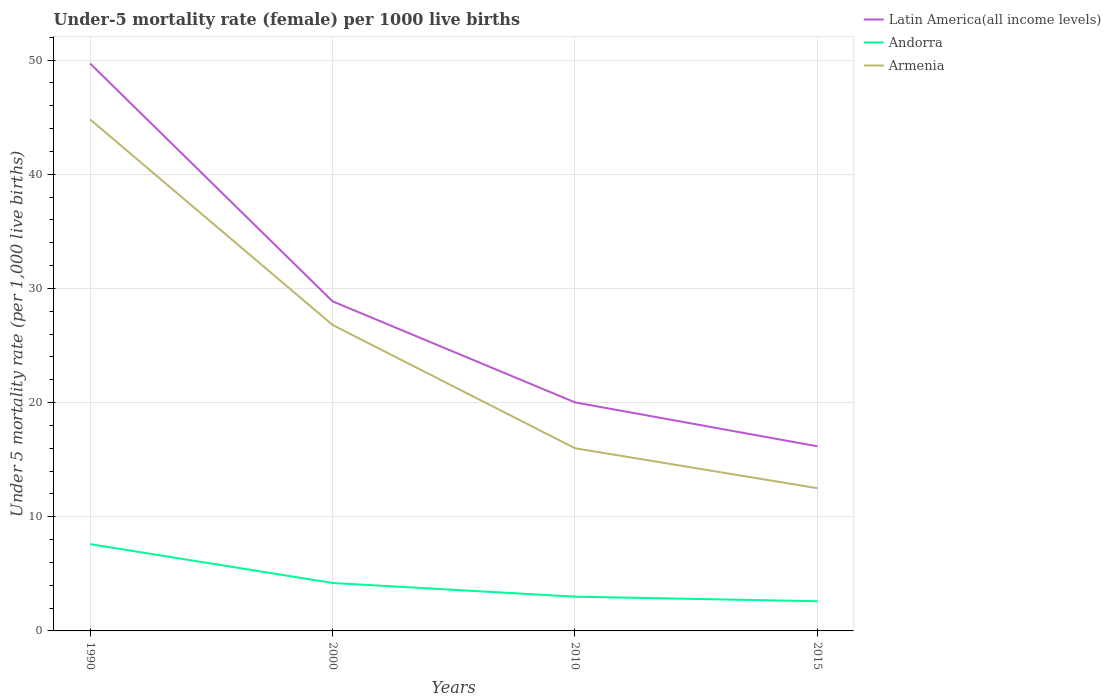Does the line corresponding to Latin America(all income levels) intersect with the line corresponding to Armenia?
Keep it short and to the point. No. Across all years, what is the maximum under-five mortality rate in Armenia?
Your answer should be very brief. 12.5. In which year was the under-five mortality rate in Latin America(all income levels) maximum?
Make the answer very short. 2015. What is the total under-five mortality rate in Armenia in the graph?
Provide a succinct answer. 28.8. What is the difference between the highest and the lowest under-five mortality rate in Andorra?
Provide a succinct answer. 1. How many lines are there?
Keep it short and to the point. 3. Does the graph contain grids?
Offer a terse response. Yes. Where does the legend appear in the graph?
Your response must be concise. Top right. What is the title of the graph?
Keep it short and to the point. Under-5 mortality rate (female) per 1000 live births. What is the label or title of the Y-axis?
Provide a short and direct response. Under 5 mortality rate (per 1,0 live births). What is the Under 5 mortality rate (per 1,000 live births) in Latin America(all income levels) in 1990?
Your answer should be very brief. 49.7. What is the Under 5 mortality rate (per 1,000 live births) of Andorra in 1990?
Give a very brief answer. 7.6. What is the Under 5 mortality rate (per 1,000 live births) of Armenia in 1990?
Keep it short and to the point. 44.8. What is the Under 5 mortality rate (per 1,000 live births) of Latin America(all income levels) in 2000?
Your answer should be very brief. 28.87. What is the Under 5 mortality rate (per 1,000 live births) of Andorra in 2000?
Provide a short and direct response. 4.2. What is the Under 5 mortality rate (per 1,000 live births) of Armenia in 2000?
Your answer should be compact. 26.8. What is the Under 5 mortality rate (per 1,000 live births) in Latin America(all income levels) in 2010?
Give a very brief answer. 20.02. What is the Under 5 mortality rate (per 1,000 live births) of Armenia in 2010?
Keep it short and to the point. 16. What is the Under 5 mortality rate (per 1,000 live births) of Latin America(all income levels) in 2015?
Provide a short and direct response. 16.17. What is the Under 5 mortality rate (per 1,000 live births) of Andorra in 2015?
Keep it short and to the point. 2.6. Across all years, what is the maximum Under 5 mortality rate (per 1,000 live births) of Latin America(all income levels)?
Give a very brief answer. 49.7. Across all years, what is the maximum Under 5 mortality rate (per 1,000 live births) of Andorra?
Ensure brevity in your answer.  7.6. Across all years, what is the maximum Under 5 mortality rate (per 1,000 live births) in Armenia?
Your response must be concise. 44.8. Across all years, what is the minimum Under 5 mortality rate (per 1,000 live births) in Latin America(all income levels)?
Ensure brevity in your answer.  16.17. Across all years, what is the minimum Under 5 mortality rate (per 1,000 live births) of Andorra?
Ensure brevity in your answer.  2.6. What is the total Under 5 mortality rate (per 1,000 live births) of Latin America(all income levels) in the graph?
Offer a terse response. 114.75. What is the total Under 5 mortality rate (per 1,000 live births) of Armenia in the graph?
Provide a short and direct response. 100.1. What is the difference between the Under 5 mortality rate (per 1,000 live births) of Latin America(all income levels) in 1990 and that in 2000?
Ensure brevity in your answer.  20.83. What is the difference between the Under 5 mortality rate (per 1,000 live births) in Andorra in 1990 and that in 2000?
Give a very brief answer. 3.4. What is the difference between the Under 5 mortality rate (per 1,000 live births) of Latin America(all income levels) in 1990 and that in 2010?
Keep it short and to the point. 29.68. What is the difference between the Under 5 mortality rate (per 1,000 live births) in Armenia in 1990 and that in 2010?
Offer a terse response. 28.8. What is the difference between the Under 5 mortality rate (per 1,000 live births) of Latin America(all income levels) in 1990 and that in 2015?
Offer a terse response. 33.53. What is the difference between the Under 5 mortality rate (per 1,000 live births) in Armenia in 1990 and that in 2015?
Your response must be concise. 32.3. What is the difference between the Under 5 mortality rate (per 1,000 live births) of Latin America(all income levels) in 2000 and that in 2010?
Offer a terse response. 8.85. What is the difference between the Under 5 mortality rate (per 1,000 live births) in Andorra in 2000 and that in 2010?
Make the answer very short. 1.2. What is the difference between the Under 5 mortality rate (per 1,000 live births) in Armenia in 2000 and that in 2010?
Ensure brevity in your answer.  10.8. What is the difference between the Under 5 mortality rate (per 1,000 live births) in Latin America(all income levels) in 2000 and that in 2015?
Your answer should be very brief. 12.7. What is the difference between the Under 5 mortality rate (per 1,000 live births) in Andorra in 2000 and that in 2015?
Offer a terse response. 1.6. What is the difference between the Under 5 mortality rate (per 1,000 live births) in Armenia in 2000 and that in 2015?
Your answer should be compact. 14.3. What is the difference between the Under 5 mortality rate (per 1,000 live births) in Latin America(all income levels) in 2010 and that in 2015?
Ensure brevity in your answer.  3.85. What is the difference between the Under 5 mortality rate (per 1,000 live births) of Latin America(all income levels) in 1990 and the Under 5 mortality rate (per 1,000 live births) of Andorra in 2000?
Make the answer very short. 45.5. What is the difference between the Under 5 mortality rate (per 1,000 live births) of Latin America(all income levels) in 1990 and the Under 5 mortality rate (per 1,000 live births) of Armenia in 2000?
Keep it short and to the point. 22.9. What is the difference between the Under 5 mortality rate (per 1,000 live births) in Andorra in 1990 and the Under 5 mortality rate (per 1,000 live births) in Armenia in 2000?
Make the answer very short. -19.2. What is the difference between the Under 5 mortality rate (per 1,000 live births) of Latin America(all income levels) in 1990 and the Under 5 mortality rate (per 1,000 live births) of Andorra in 2010?
Offer a terse response. 46.7. What is the difference between the Under 5 mortality rate (per 1,000 live births) of Latin America(all income levels) in 1990 and the Under 5 mortality rate (per 1,000 live births) of Armenia in 2010?
Your response must be concise. 33.7. What is the difference between the Under 5 mortality rate (per 1,000 live births) in Andorra in 1990 and the Under 5 mortality rate (per 1,000 live births) in Armenia in 2010?
Provide a short and direct response. -8.4. What is the difference between the Under 5 mortality rate (per 1,000 live births) of Latin America(all income levels) in 1990 and the Under 5 mortality rate (per 1,000 live births) of Andorra in 2015?
Offer a terse response. 47.1. What is the difference between the Under 5 mortality rate (per 1,000 live births) of Latin America(all income levels) in 1990 and the Under 5 mortality rate (per 1,000 live births) of Armenia in 2015?
Your answer should be compact. 37.2. What is the difference between the Under 5 mortality rate (per 1,000 live births) in Latin America(all income levels) in 2000 and the Under 5 mortality rate (per 1,000 live births) in Andorra in 2010?
Offer a very short reply. 25.87. What is the difference between the Under 5 mortality rate (per 1,000 live births) of Latin America(all income levels) in 2000 and the Under 5 mortality rate (per 1,000 live births) of Armenia in 2010?
Give a very brief answer. 12.87. What is the difference between the Under 5 mortality rate (per 1,000 live births) of Latin America(all income levels) in 2000 and the Under 5 mortality rate (per 1,000 live births) of Andorra in 2015?
Offer a very short reply. 26.27. What is the difference between the Under 5 mortality rate (per 1,000 live births) in Latin America(all income levels) in 2000 and the Under 5 mortality rate (per 1,000 live births) in Armenia in 2015?
Offer a very short reply. 16.37. What is the difference between the Under 5 mortality rate (per 1,000 live births) in Latin America(all income levels) in 2010 and the Under 5 mortality rate (per 1,000 live births) in Andorra in 2015?
Offer a very short reply. 17.42. What is the difference between the Under 5 mortality rate (per 1,000 live births) of Latin America(all income levels) in 2010 and the Under 5 mortality rate (per 1,000 live births) of Armenia in 2015?
Keep it short and to the point. 7.52. What is the difference between the Under 5 mortality rate (per 1,000 live births) in Andorra in 2010 and the Under 5 mortality rate (per 1,000 live births) in Armenia in 2015?
Provide a short and direct response. -9.5. What is the average Under 5 mortality rate (per 1,000 live births) of Latin America(all income levels) per year?
Ensure brevity in your answer.  28.69. What is the average Under 5 mortality rate (per 1,000 live births) of Andorra per year?
Offer a terse response. 4.35. What is the average Under 5 mortality rate (per 1,000 live births) of Armenia per year?
Make the answer very short. 25.02. In the year 1990, what is the difference between the Under 5 mortality rate (per 1,000 live births) in Latin America(all income levels) and Under 5 mortality rate (per 1,000 live births) in Andorra?
Offer a terse response. 42.1. In the year 1990, what is the difference between the Under 5 mortality rate (per 1,000 live births) of Latin America(all income levels) and Under 5 mortality rate (per 1,000 live births) of Armenia?
Provide a succinct answer. 4.9. In the year 1990, what is the difference between the Under 5 mortality rate (per 1,000 live births) in Andorra and Under 5 mortality rate (per 1,000 live births) in Armenia?
Your response must be concise. -37.2. In the year 2000, what is the difference between the Under 5 mortality rate (per 1,000 live births) in Latin America(all income levels) and Under 5 mortality rate (per 1,000 live births) in Andorra?
Ensure brevity in your answer.  24.67. In the year 2000, what is the difference between the Under 5 mortality rate (per 1,000 live births) in Latin America(all income levels) and Under 5 mortality rate (per 1,000 live births) in Armenia?
Provide a succinct answer. 2.07. In the year 2000, what is the difference between the Under 5 mortality rate (per 1,000 live births) of Andorra and Under 5 mortality rate (per 1,000 live births) of Armenia?
Provide a short and direct response. -22.6. In the year 2010, what is the difference between the Under 5 mortality rate (per 1,000 live births) of Latin America(all income levels) and Under 5 mortality rate (per 1,000 live births) of Andorra?
Make the answer very short. 17.02. In the year 2010, what is the difference between the Under 5 mortality rate (per 1,000 live births) in Latin America(all income levels) and Under 5 mortality rate (per 1,000 live births) in Armenia?
Offer a very short reply. 4.02. In the year 2010, what is the difference between the Under 5 mortality rate (per 1,000 live births) of Andorra and Under 5 mortality rate (per 1,000 live births) of Armenia?
Offer a very short reply. -13. In the year 2015, what is the difference between the Under 5 mortality rate (per 1,000 live births) of Latin America(all income levels) and Under 5 mortality rate (per 1,000 live births) of Andorra?
Offer a very short reply. 13.57. In the year 2015, what is the difference between the Under 5 mortality rate (per 1,000 live births) in Latin America(all income levels) and Under 5 mortality rate (per 1,000 live births) in Armenia?
Your response must be concise. 3.67. What is the ratio of the Under 5 mortality rate (per 1,000 live births) of Latin America(all income levels) in 1990 to that in 2000?
Provide a succinct answer. 1.72. What is the ratio of the Under 5 mortality rate (per 1,000 live births) in Andorra in 1990 to that in 2000?
Provide a short and direct response. 1.81. What is the ratio of the Under 5 mortality rate (per 1,000 live births) of Armenia in 1990 to that in 2000?
Your answer should be very brief. 1.67. What is the ratio of the Under 5 mortality rate (per 1,000 live births) of Latin America(all income levels) in 1990 to that in 2010?
Provide a succinct answer. 2.48. What is the ratio of the Under 5 mortality rate (per 1,000 live births) in Andorra in 1990 to that in 2010?
Offer a terse response. 2.53. What is the ratio of the Under 5 mortality rate (per 1,000 live births) in Armenia in 1990 to that in 2010?
Your answer should be very brief. 2.8. What is the ratio of the Under 5 mortality rate (per 1,000 live births) of Latin America(all income levels) in 1990 to that in 2015?
Your answer should be very brief. 3.07. What is the ratio of the Under 5 mortality rate (per 1,000 live births) of Andorra in 1990 to that in 2015?
Make the answer very short. 2.92. What is the ratio of the Under 5 mortality rate (per 1,000 live births) in Armenia in 1990 to that in 2015?
Offer a very short reply. 3.58. What is the ratio of the Under 5 mortality rate (per 1,000 live births) of Latin America(all income levels) in 2000 to that in 2010?
Your response must be concise. 1.44. What is the ratio of the Under 5 mortality rate (per 1,000 live births) of Armenia in 2000 to that in 2010?
Make the answer very short. 1.68. What is the ratio of the Under 5 mortality rate (per 1,000 live births) of Latin America(all income levels) in 2000 to that in 2015?
Offer a terse response. 1.79. What is the ratio of the Under 5 mortality rate (per 1,000 live births) in Andorra in 2000 to that in 2015?
Make the answer very short. 1.62. What is the ratio of the Under 5 mortality rate (per 1,000 live births) of Armenia in 2000 to that in 2015?
Your answer should be compact. 2.14. What is the ratio of the Under 5 mortality rate (per 1,000 live births) in Latin America(all income levels) in 2010 to that in 2015?
Make the answer very short. 1.24. What is the ratio of the Under 5 mortality rate (per 1,000 live births) of Andorra in 2010 to that in 2015?
Your answer should be compact. 1.15. What is the ratio of the Under 5 mortality rate (per 1,000 live births) of Armenia in 2010 to that in 2015?
Keep it short and to the point. 1.28. What is the difference between the highest and the second highest Under 5 mortality rate (per 1,000 live births) in Latin America(all income levels)?
Offer a terse response. 20.83. What is the difference between the highest and the second highest Under 5 mortality rate (per 1,000 live births) of Andorra?
Offer a very short reply. 3.4. What is the difference between the highest and the second highest Under 5 mortality rate (per 1,000 live births) in Armenia?
Your answer should be compact. 18. What is the difference between the highest and the lowest Under 5 mortality rate (per 1,000 live births) of Latin America(all income levels)?
Your response must be concise. 33.53. What is the difference between the highest and the lowest Under 5 mortality rate (per 1,000 live births) of Armenia?
Ensure brevity in your answer.  32.3. 